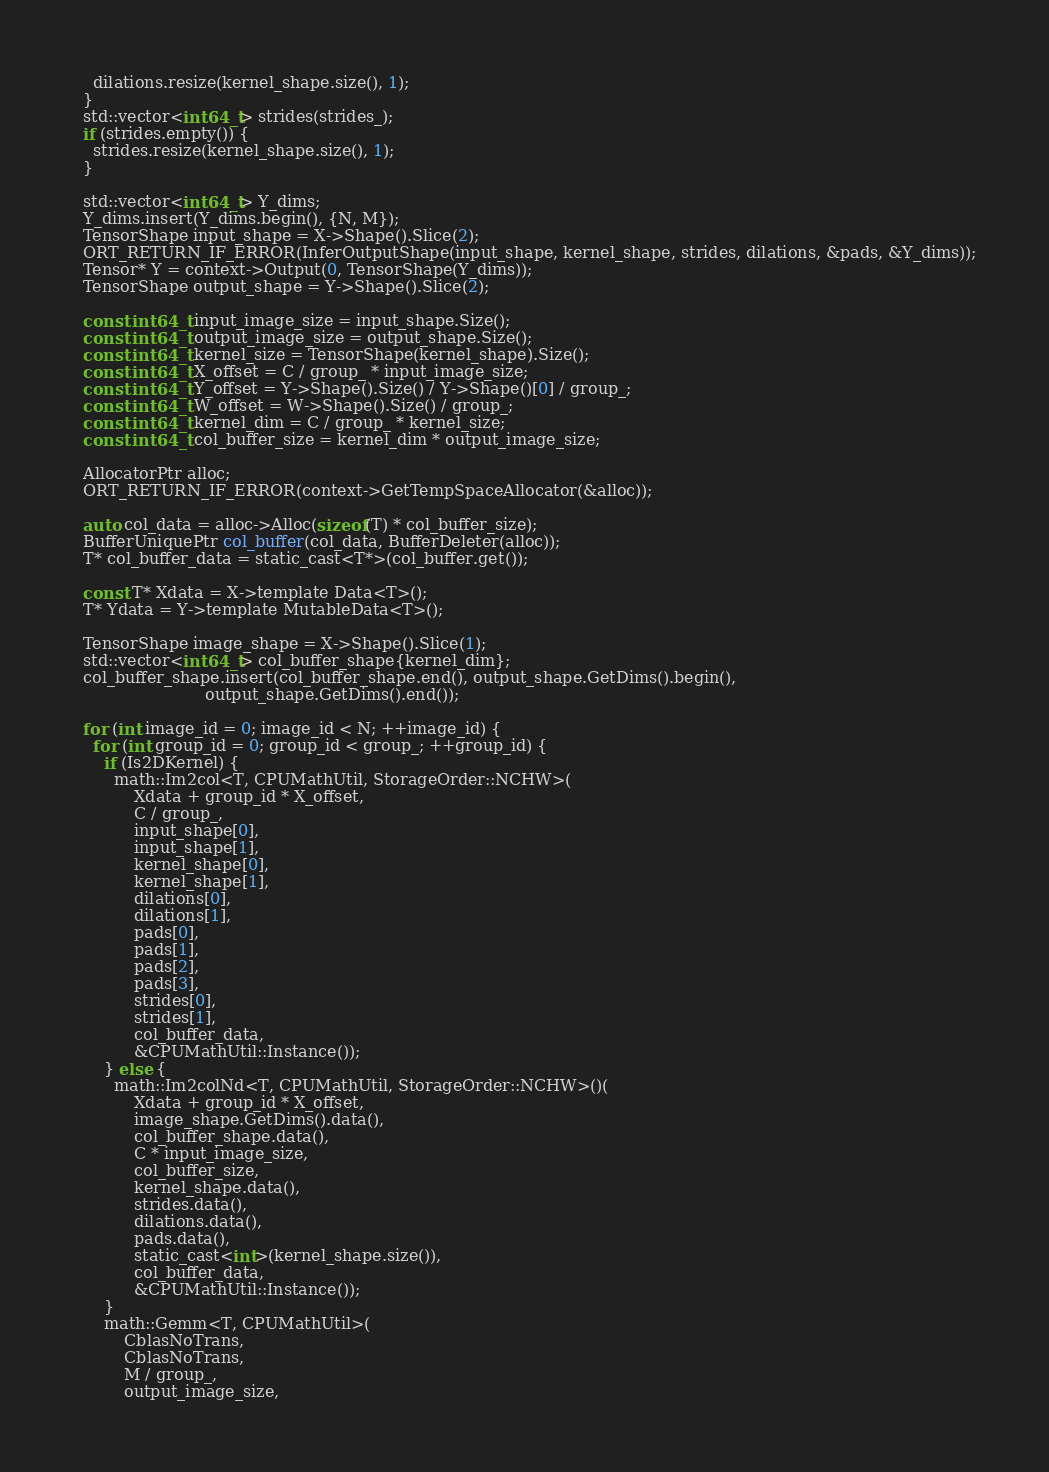<code> <loc_0><loc_0><loc_500><loc_500><_C_>    dilations.resize(kernel_shape.size(), 1);
  }
  std::vector<int64_t> strides(strides_);
  if (strides.empty()) {
    strides.resize(kernel_shape.size(), 1);
  }

  std::vector<int64_t> Y_dims;
  Y_dims.insert(Y_dims.begin(), {N, M});
  TensorShape input_shape = X->Shape().Slice(2);
  ORT_RETURN_IF_ERROR(InferOutputShape(input_shape, kernel_shape, strides, dilations, &pads, &Y_dims));
  Tensor* Y = context->Output(0, TensorShape(Y_dims));
  TensorShape output_shape = Y->Shape().Slice(2);

  const int64_t input_image_size = input_shape.Size();
  const int64_t output_image_size = output_shape.Size();
  const int64_t kernel_size = TensorShape(kernel_shape).Size();
  const int64_t X_offset = C / group_ * input_image_size;
  const int64_t Y_offset = Y->Shape().Size() / Y->Shape()[0] / group_;
  const int64_t W_offset = W->Shape().Size() / group_;
  const int64_t kernel_dim = C / group_ * kernel_size;
  const int64_t col_buffer_size = kernel_dim * output_image_size;

  AllocatorPtr alloc;
  ORT_RETURN_IF_ERROR(context->GetTempSpaceAllocator(&alloc));

  auto col_data = alloc->Alloc(sizeof(T) * col_buffer_size);
  BufferUniquePtr col_buffer(col_data, BufferDeleter(alloc));
  T* col_buffer_data = static_cast<T*>(col_buffer.get());

  const T* Xdata = X->template Data<T>();
  T* Ydata = Y->template MutableData<T>();

  TensorShape image_shape = X->Shape().Slice(1);
  std::vector<int64_t> col_buffer_shape{kernel_dim};
  col_buffer_shape.insert(col_buffer_shape.end(), output_shape.GetDims().begin(),
                          output_shape.GetDims().end());

  for (int image_id = 0; image_id < N; ++image_id) {
    for (int group_id = 0; group_id < group_; ++group_id) {
      if (Is2DKernel) {
        math::Im2col<T, CPUMathUtil, StorageOrder::NCHW>(
            Xdata + group_id * X_offset,
            C / group_,
            input_shape[0],
            input_shape[1],
            kernel_shape[0],
            kernel_shape[1],
            dilations[0],
            dilations[1],
            pads[0],
            pads[1],
            pads[2],
            pads[3],
            strides[0],
            strides[1],
            col_buffer_data,
            &CPUMathUtil::Instance());
      } else {
        math::Im2colNd<T, CPUMathUtil, StorageOrder::NCHW>()(
            Xdata + group_id * X_offset,
            image_shape.GetDims().data(),
            col_buffer_shape.data(),
            C * input_image_size,
            col_buffer_size,
            kernel_shape.data(),
            strides.data(),
            dilations.data(),
            pads.data(),
            static_cast<int>(kernel_shape.size()),
            col_buffer_data,
            &CPUMathUtil::Instance());
      }
      math::Gemm<T, CPUMathUtil>(
          CblasNoTrans,
          CblasNoTrans,
          M / group_,
          output_image_size,</code> 